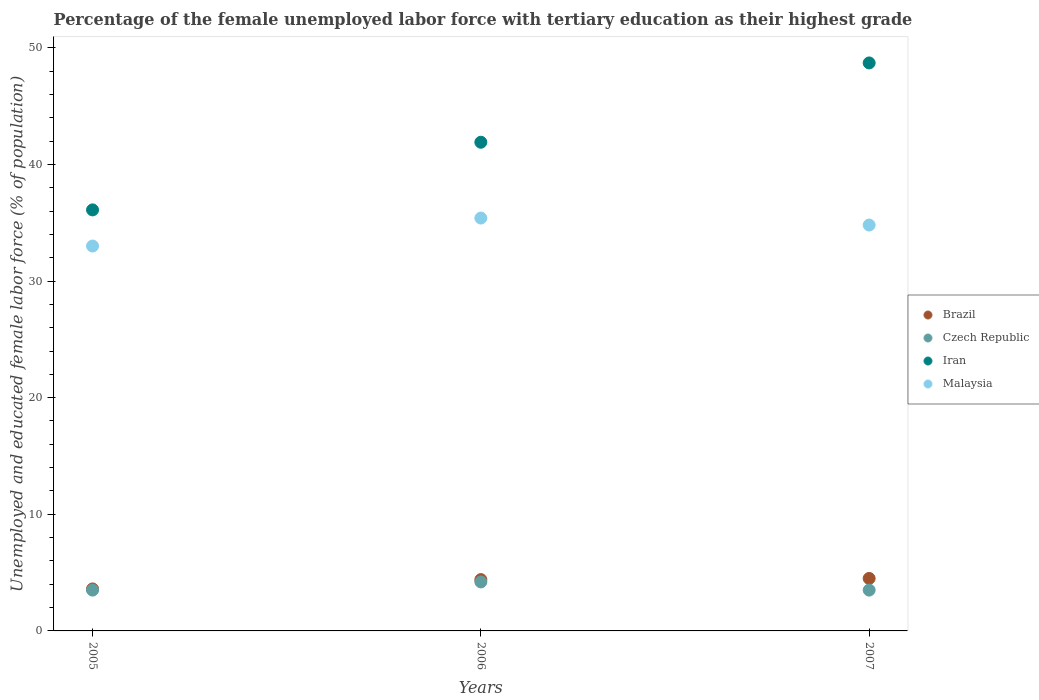Is the number of dotlines equal to the number of legend labels?
Make the answer very short. Yes. What is the percentage of the unemployed female labor force with tertiary education in Malaysia in 2005?
Ensure brevity in your answer.  33. Across all years, what is the maximum percentage of the unemployed female labor force with tertiary education in Czech Republic?
Your response must be concise. 4.2. Across all years, what is the minimum percentage of the unemployed female labor force with tertiary education in Iran?
Make the answer very short. 36.1. In which year was the percentage of the unemployed female labor force with tertiary education in Brazil minimum?
Keep it short and to the point. 2005. What is the total percentage of the unemployed female labor force with tertiary education in Malaysia in the graph?
Offer a terse response. 103.2. What is the difference between the percentage of the unemployed female labor force with tertiary education in Brazil in 2005 and that in 2007?
Ensure brevity in your answer.  -0.9. What is the difference between the percentage of the unemployed female labor force with tertiary education in Malaysia in 2005 and the percentage of the unemployed female labor force with tertiary education in Brazil in 2007?
Make the answer very short. 28.5. What is the average percentage of the unemployed female labor force with tertiary education in Malaysia per year?
Your answer should be compact. 34.4. In the year 2007, what is the difference between the percentage of the unemployed female labor force with tertiary education in Iran and percentage of the unemployed female labor force with tertiary education in Malaysia?
Keep it short and to the point. 13.9. What is the ratio of the percentage of the unemployed female labor force with tertiary education in Malaysia in 2006 to that in 2007?
Ensure brevity in your answer.  1.02. Is the percentage of the unemployed female labor force with tertiary education in Czech Republic in 2005 less than that in 2006?
Give a very brief answer. Yes. What is the difference between the highest and the second highest percentage of the unemployed female labor force with tertiary education in Malaysia?
Give a very brief answer. 0.6. What is the difference between the highest and the lowest percentage of the unemployed female labor force with tertiary education in Iran?
Ensure brevity in your answer.  12.6. Is the sum of the percentage of the unemployed female labor force with tertiary education in Brazil in 2005 and 2007 greater than the maximum percentage of the unemployed female labor force with tertiary education in Czech Republic across all years?
Provide a succinct answer. Yes. Is it the case that in every year, the sum of the percentage of the unemployed female labor force with tertiary education in Malaysia and percentage of the unemployed female labor force with tertiary education in Iran  is greater than the percentage of the unemployed female labor force with tertiary education in Brazil?
Your response must be concise. Yes. Is the percentage of the unemployed female labor force with tertiary education in Malaysia strictly greater than the percentage of the unemployed female labor force with tertiary education in Czech Republic over the years?
Your response must be concise. Yes. Is the percentage of the unemployed female labor force with tertiary education in Czech Republic strictly less than the percentage of the unemployed female labor force with tertiary education in Iran over the years?
Ensure brevity in your answer.  Yes. How many dotlines are there?
Offer a terse response. 4. What is the difference between two consecutive major ticks on the Y-axis?
Provide a short and direct response. 10. Are the values on the major ticks of Y-axis written in scientific E-notation?
Your response must be concise. No. How many legend labels are there?
Offer a very short reply. 4. What is the title of the graph?
Offer a terse response. Percentage of the female unemployed labor force with tertiary education as their highest grade. Does "Antigua and Barbuda" appear as one of the legend labels in the graph?
Keep it short and to the point. No. What is the label or title of the Y-axis?
Offer a very short reply. Unemployed and educated female labor force (% of population). What is the Unemployed and educated female labor force (% of population) of Brazil in 2005?
Give a very brief answer. 3.6. What is the Unemployed and educated female labor force (% of population) in Iran in 2005?
Your response must be concise. 36.1. What is the Unemployed and educated female labor force (% of population) in Brazil in 2006?
Your response must be concise. 4.4. What is the Unemployed and educated female labor force (% of population) in Czech Republic in 2006?
Keep it short and to the point. 4.2. What is the Unemployed and educated female labor force (% of population) of Iran in 2006?
Your answer should be very brief. 41.9. What is the Unemployed and educated female labor force (% of population) in Malaysia in 2006?
Your answer should be compact. 35.4. What is the Unemployed and educated female labor force (% of population) of Brazil in 2007?
Make the answer very short. 4.5. What is the Unemployed and educated female labor force (% of population) of Iran in 2007?
Offer a very short reply. 48.7. What is the Unemployed and educated female labor force (% of population) in Malaysia in 2007?
Offer a very short reply. 34.8. Across all years, what is the maximum Unemployed and educated female labor force (% of population) of Czech Republic?
Your answer should be very brief. 4.2. Across all years, what is the maximum Unemployed and educated female labor force (% of population) of Iran?
Your response must be concise. 48.7. Across all years, what is the maximum Unemployed and educated female labor force (% of population) in Malaysia?
Give a very brief answer. 35.4. Across all years, what is the minimum Unemployed and educated female labor force (% of population) of Brazil?
Ensure brevity in your answer.  3.6. Across all years, what is the minimum Unemployed and educated female labor force (% of population) in Czech Republic?
Provide a succinct answer. 3.5. Across all years, what is the minimum Unemployed and educated female labor force (% of population) of Iran?
Offer a terse response. 36.1. Across all years, what is the minimum Unemployed and educated female labor force (% of population) in Malaysia?
Provide a short and direct response. 33. What is the total Unemployed and educated female labor force (% of population) of Brazil in the graph?
Offer a terse response. 12.5. What is the total Unemployed and educated female labor force (% of population) in Iran in the graph?
Provide a short and direct response. 126.7. What is the total Unemployed and educated female labor force (% of population) in Malaysia in the graph?
Make the answer very short. 103.2. What is the difference between the Unemployed and educated female labor force (% of population) in Iran in 2005 and that in 2006?
Provide a short and direct response. -5.8. What is the difference between the Unemployed and educated female labor force (% of population) in Malaysia in 2005 and that in 2006?
Ensure brevity in your answer.  -2.4. What is the difference between the Unemployed and educated female labor force (% of population) in Brazil in 2005 and that in 2007?
Your response must be concise. -0.9. What is the difference between the Unemployed and educated female labor force (% of population) in Iran in 2005 and that in 2007?
Offer a terse response. -12.6. What is the difference between the Unemployed and educated female labor force (% of population) of Malaysia in 2005 and that in 2007?
Make the answer very short. -1.8. What is the difference between the Unemployed and educated female labor force (% of population) of Brazil in 2006 and that in 2007?
Your answer should be compact. -0.1. What is the difference between the Unemployed and educated female labor force (% of population) of Iran in 2006 and that in 2007?
Make the answer very short. -6.8. What is the difference between the Unemployed and educated female labor force (% of population) of Malaysia in 2006 and that in 2007?
Your response must be concise. 0.6. What is the difference between the Unemployed and educated female labor force (% of population) in Brazil in 2005 and the Unemployed and educated female labor force (% of population) in Czech Republic in 2006?
Give a very brief answer. -0.6. What is the difference between the Unemployed and educated female labor force (% of population) in Brazil in 2005 and the Unemployed and educated female labor force (% of population) in Iran in 2006?
Your answer should be very brief. -38.3. What is the difference between the Unemployed and educated female labor force (% of population) of Brazil in 2005 and the Unemployed and educated female labor force (% of population) of Malaysia in 2006?
Offer a terse response. -31.8. What is the difference between the Unemployed and educated female labor force (% of population) in Czech Republic in 2005 and the Unemployed and educated female labor force (% of population) in Iran in 2006?
Keep it short and to the point. -38.4. What is the difference between the Unemployed and educated female labor force (% of population) of Czech Republic in 2005 and the Unemployed and educated female labor force (% of population) of Malaysia in 2006?
Your response must be concise. -31.9. What is the difference between the Unemployed and educated female labor force (% of population) in Iran in 2005 and the Unemployed and educated female labor force (% of population) in Malaysia in 2006?
Ensure brevity in your answer.  0.7. What is the difference between the Unemployed and educated female labor force (% of population) of Brazil in 2005 and the Unemployed and educated female labor force (% of population) of Czech Republic in 2007?
Give a very brief answer. 0.1. What is the difference between the Unemployed and educated female labor force (% of population) of Brazil in 2005 and the Unemployed and educated female labor force (% of population) of Iran in 2007?
Your response must be concise. -45.1. What is the difference between the Unemployed and educated female labor force (% of population) in Brazil in 2005 and the Unemployed and educated female labor force (% of population) in Malaysia in 2007?
Give a very brief answer. -31.2. What is the difference between the Unemployed and educated female labor force (% of population) in Czech Republic in 2005 and the Unemployed and educated female labor force (% of population) in Iran in 2007?
Offer a very short reply. -45.2. What is the difference between the Unemployed and educated female labor force (% of population) of Czech Republic in 2005 and the Unemployed and educated female labor force (% of population) of Malaysia in 2007?
Your answer should be compact. -31.3. What is the difference between the Unemployed and educated female labor force (% of population) in Iran in 2005 and the Unemployed and educated female labor force (% of population) in Malaysia in 2007?
Keep it short and to the point. 1.3. What is the difference between the Unemployed and educated female labor force (% of population) of Brazil in 2006 and the Unemployed and educated female labor force (% of population) of Czech Republic in 2007?
Provide a short and direct response. 0.9. What is the difference between the Unemployed and educated female labor force (% of population) of Brazil in 2006 and the Unemployed and educated female labor force (% of population) of Iran in 2007?
Offer a very short reply. -44.3. What is the difference between the Unemployed and educated female labor force (% of population) in Brazil in 2006 and the Unemployed and educated female labor force (% of population) in Malaysia in 2007?
Offer a terse response. -30.4. What is the difference between the Unemployed and educated female labor force (% of population) of Czech Republic in 2006 and the Unemployed and educated female labor force (% of population) of Iran in 2007?
Make the answer very short. -44.5. What is the difference between the Unemployed and educated female labor force (% of population) in Czech Republic in 2006 and the Unemployed and educated female labor force (% of population) in Malaysia in 2007?
Keep it short and to the point. -30.6. What is the average Unemployed and educated female labor force (% of population) in Brazil per year?
Provide a succinct answer. 4.17. What is the average Unemployed and educated female labor force (% of population) in Czech Republic per year?
Provide a short and direct response. 3.73. What is the average Unemployed and educated female labor force (% of population) of Iran per year?
Make the answer very short. 42.23. What is the average Unemployed and educated female labor force (% of population) of Malaysia per year?
Your answer should be very brief. 34.4. In the year 2005, what is the difference between the Unemployed and educated female labor force (% of population) in Brazil and Unemployed and educated female labor force (% of population) in Czech Republic?
Your answer should be compact. 0.1. In the year 2005, what is the difference between the Unemployed and educated female labor force (% of population) of Brazil and Unemployed and educated female labor force (% of population) of Iran?
Your answer should be compact. -32.5. In the year 2005, what is the difference between the Unemployed and educated female labor force (% of population) in Brazil and Unemployed and educated female labor force (% of population) in Malaysia?
Ensure brevity in your answer.  -29.4. In the year 2005, what is the difference between the Unemployed and educated female labor force (% of population) in Czech Republic and Unemployed and educated female labor force (% of population) in Iran?
Your response must be concise. -32.6. In the year 2005, what is the difference between the Unemployed and educated female labor force (% of population) in Czech Republic and Unemployed and educated female labor force (% of population) in Malaysia?
Your response must be concise. -29.5. In the year 2005, what is the difference between the Unemployed and educated female labor force (% of population) of Iran and Unemployed and educated female labor force (% of population) of Malaysia?
Make the answer very short. 3.1. In the year 2006, what is the difference between the Unemployed and educated female labor force (% of population) in Brazil and Unemployed and educated female labor force (% of population) in Czech Republic?
Offer a very short reply. 0.2. In the year 2006, what is the difference between the Unemployed and educated female labor force (% of population) of Brazil and Unemployed and educated female labor force (% of population) of Iran?
Your answer should be very brief. -37.5. In the year 2006, what is the difference between the Unemployed and educated female labor force (% of population) of Brazil and Unemployed and educated female labor force (% of population) of Malaysia?
Provide a short and direct response. -31. In the year 2006, what is the difference between the Unemployed and educated female labor force (% of population) in Czech Republic and Unemployed and educated female labor force (% of population) in Iran?
Your response must be concise. -37.7. In the year 2006, what is the difference between the Unemployed and educated female labor force (% of population) of Czech Republic and Unemployed and educated female labor force (% of population) of Malaysia?
Your response must be concise. -31.2. In the year 2007, what is the difference between the Unemployed and educated female labor force (% of population) in Brazil and Unemployed and educated female labor force (% of population) in Czech Republic?
Offer a terse response. 1. In the year 2007, what is the difference between the Unemployed and educated female labor force (% of population) of Brazil and Unemployed and educated female labor force (% of population) of Iran?
Give a very brief answer. -44.2. In the year 2007, what is the difference between the Unemployed and educated female labor force (% of population) in Brazil and Unemployed and educated female labor force (% of population) in Malaysia?
Provide a succinct answer. -30.3. In the year 2007, what is the difference between the Unemployed and educated female labor force (% of population) of Czech Republic and Unemployed and educated female labor force (% of population) of Iran?
Provide a short and direct response. -45.2. In the year 2007, what is the difference between the Unemployed and educated female labor force (% of population) of Czech Republic and Unemployed and educated female labor force (% of population) of Malaysia?
Make the answer very short. -31.3. In the year 2007, what is the difference between the Unemployed and educated female labor force (% of population) in Iran and Unemployed and educated female labor force (% of population) in Malaysia?
Make the answer very short. 13.9. What is the ratio of the Unemployed and educated female labor force (% of population) in Brazil in 2005 to that in 2006?
Offer a terse response. 0.82. What is the ratio of the Unemployed and educated female labor force (% of population) of Czech Republic in 2005 to that in 2006?
Your answer should be very brief. 0.83. What is the ratio of the Unemployed and educated female labor force (% of population) in Iran in 2005 to that in 2006?
Your response must be concise. 0.86. What is the ratio of the Unemployed and educated female labor force (% of population) in Malaysia in 2005 to that in 2006?
Offer a very short reply. 0.93. What is the ratio of the Unemployed and educated female labor force (% of population) of Iran in 2005 to that in 2007?
Offer a terse response. 0.74. What is the ratio of the Unemployed and educated female labor force (% of population) in Malaysia in 2005 to that in 2007?
Provide a succinct answer. 0.95. What is the ratio of the Unemployed and educated female labor force (% of population) of Brazil in 2006 to that in 2007?
Your answer should be very brief. 0.98. What is the ratio of the Unemployed and educated female labor force (% of population) in Iran in 2006 to that in 2007?
Keep it short and to the point. 0.86. What is the ratio of the Unemployed and educated female labor force (% of population) in Malaysia in 2006 to that in 2007?
Provide a short and direct response. 1.02. What is the difference between the highest and the lowest Unemployed and educated female labor force (% of population) in Brazil?
Keep it short and to the point. 0.9. What is the difference between the highest and the lowest Unemployed and educated female labor force (% of population) in Czech Republic?
Make the answer very short. 0.7. What is the difference between the highest and the lowest Unemployed and educated female labor force (% of population) in Iran?
Your response must be concise. 12.6. 